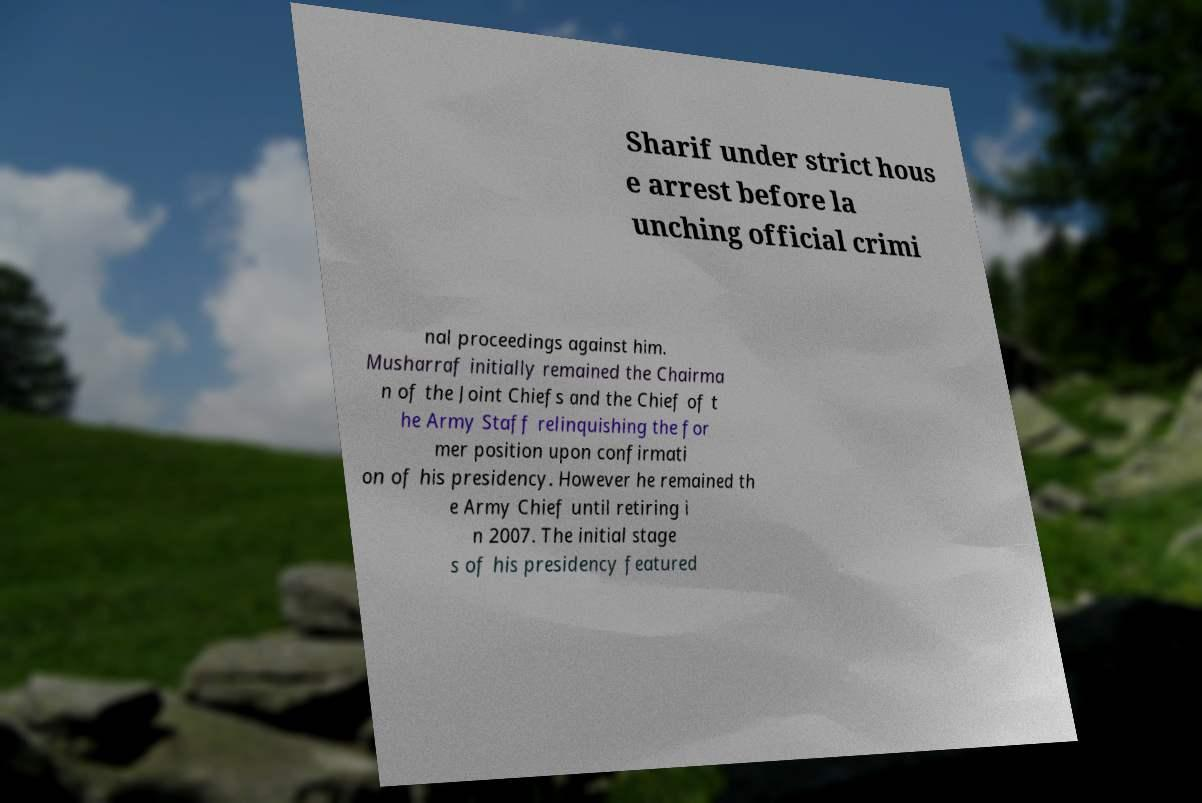Can you accurately transcribe the text from the provided image for me? Sharif under strict hous e arrest before la unching official crimi nal proceedings against him. Musharraf initially remained the Chairma n of the Joint Chiefs and the Chief of t he Army Staff relinquishing the for mer position upon confirmati on of his presidency. However he remained th e Army Chief until retiring i n 2007. The initial stage s of his presidency featured 